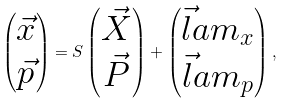<formula> <loc_0><loc_0><loc_500><loc_500>\begin{pmatrix} \vec { x } \\ \vec { p } \end{pmatrix} = S \begin{pmatrix} \vec { X } \\ \vec { P } \end{pmatrix} + \begin{pmatrix} \vec { l } a m _ { x } \\ \vec { l } a m _ { p } \end{pmatrix} ,</formula> 